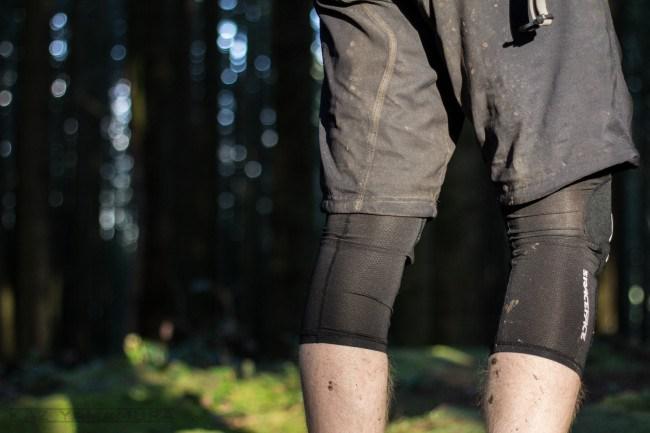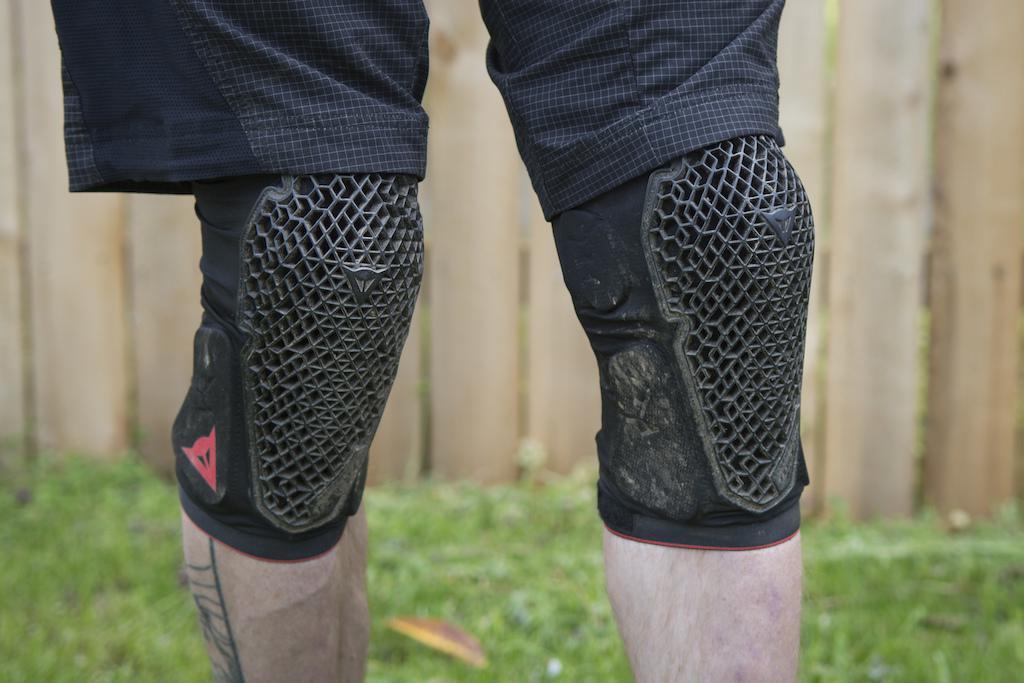The first image is the image on the left, the second image is the image on the right. Considering the images on both sides, is "An image shows a front view of a pair of legs wearing mesh-like kneepads." valid? Answer yes or no. Yes. The first image is the image on the left, the second image is the image on the right. Evaluate the accuracy of this statement regarding the images: "Both images show kneepads modelled on human legs.". Is it true? Answer yes or no. Yes. 